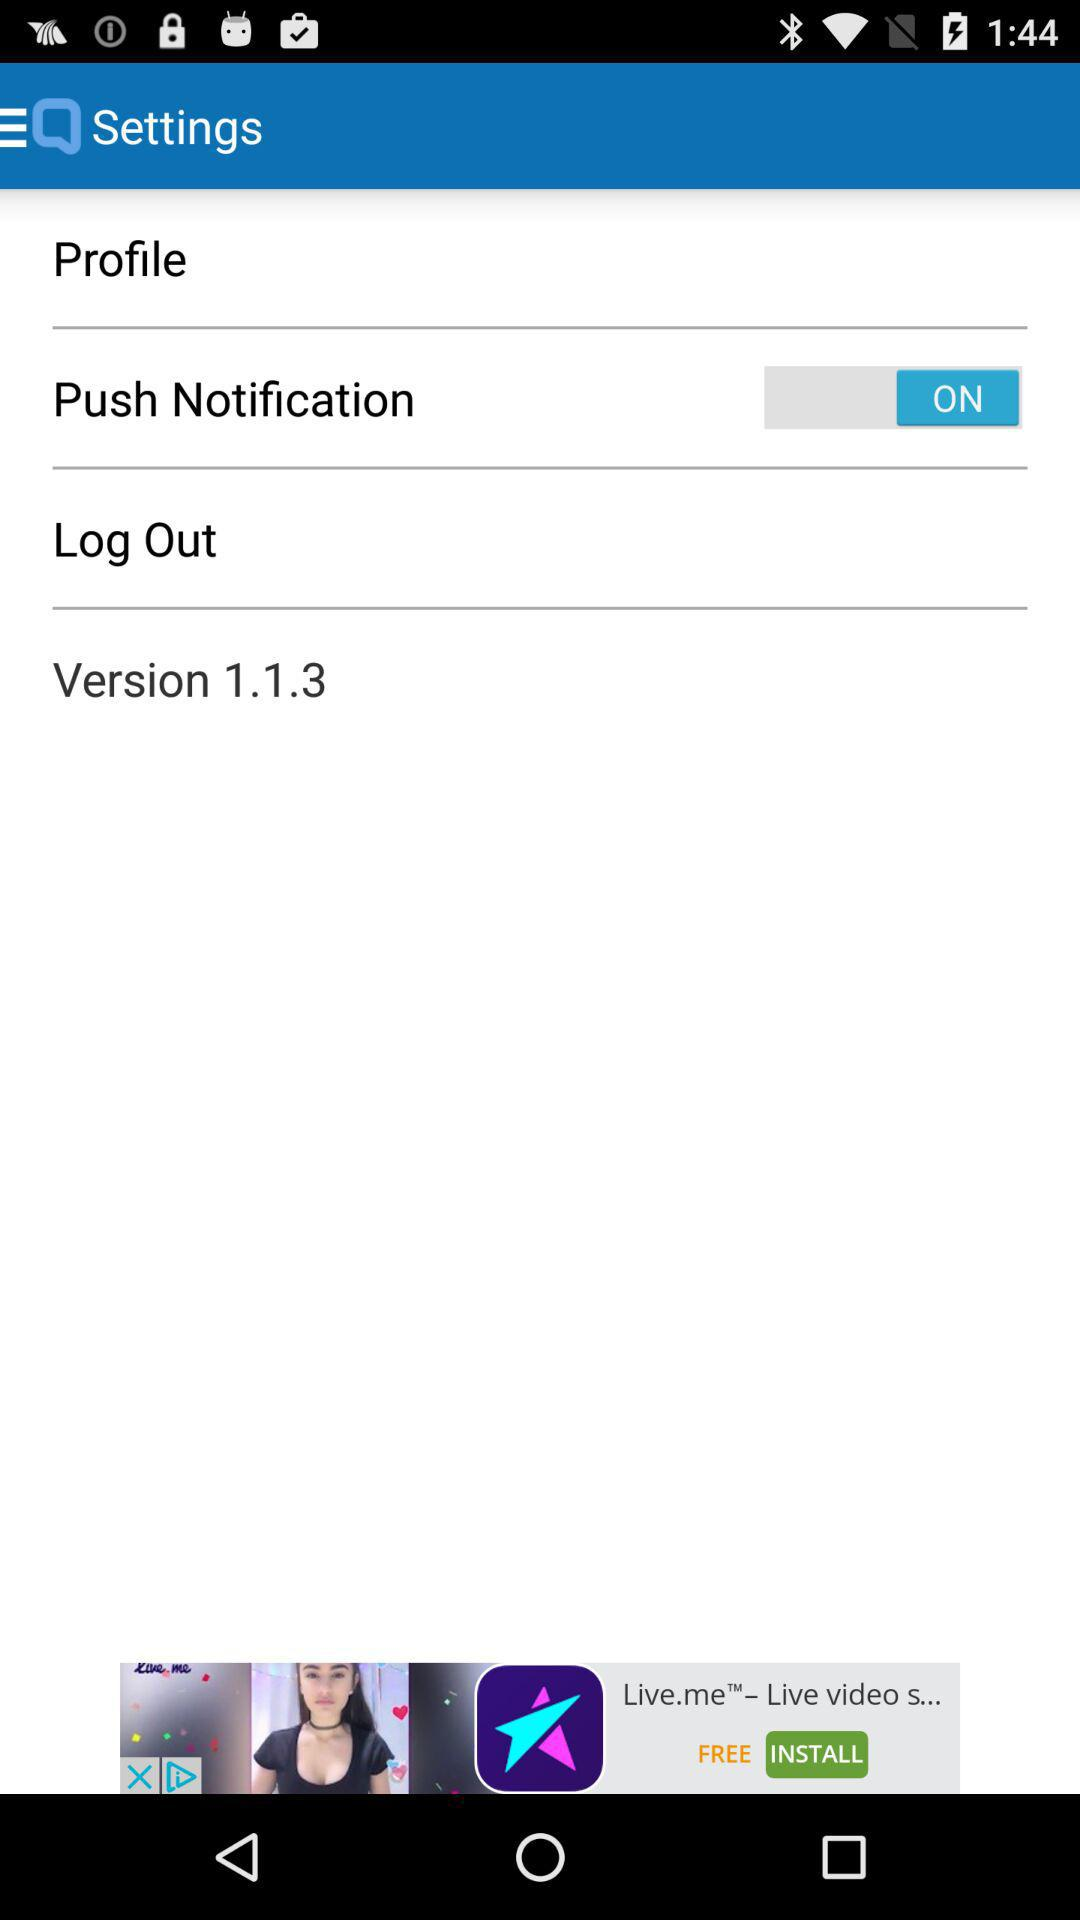What is the version? The version is 1.1.3. 